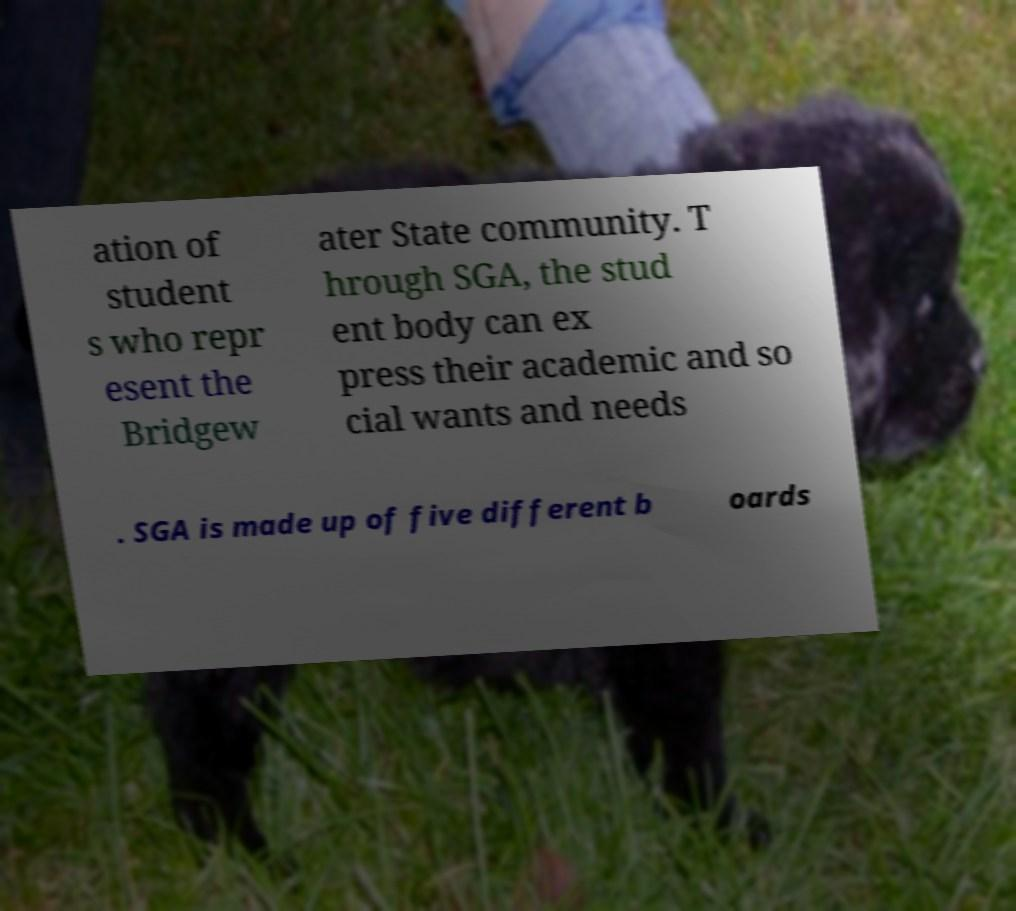Can you read and provide the text displayed in the image?This photo seems to have some interesting text. Can you extract and type it out for me? ation of student s who repr esent the Bridgew ater State community. T hrough SGA, the stud ent body can ex press their academic and so cial wants and needs . SGA is made up of five different b oards 